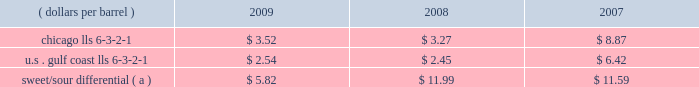Our refining and wholesale marketing gross margin is the difference between the prices of refined products sold and the costs of crude oil and other charge and blendstocks refined , including the costs to transport these inputs to our refineries , the costs of purchased products and manufacturing expenses , including depreciation .
The crack spread is a measure of the difference between market prices for refined products and crude oil , commonly used by the industry as a proxy for the refining margin .
Crack spreads can fluctuate significantly , particularly when prices of refined products do not move in the same relationship as the cost of crude oil .
As a performance benchmark and a comparison with other industry participants , we calculate midwest ( chicago ) and u.s .
Gulf coast crack spreads that we feel most closely track our operations and slate of products .
Posted light louisiana sweet ( 201clls 201d ) prices and a 6-3-2-1 ratio of products ( 6 barrels of crude oil producing 3 barrels of gasoline , 2 barrels of distillate and 1 barrel of residual fuel ) are used for the crack spread calculation .
Our refineries can process significant amounts of sour crude oil which typically can be purchased at a discount to sweet crude oil .
The amount of this discount , the sweet/sour differential , can vary significantly causing our refining and wholesale marketing gross margin to differ from the crack spreads which are based upon sweet crude .
In general , a larger sweet/sour differential will enhance our refining and wholesale marketing gross margin .
In 2009 , the sweet/sour differential narrowed , due to a variety of worldwide economic and petroleum industry related factors , primarily related to lower hydrocarbon demand .
Sour crude accounted for 50 percent , 52 percent and 54 percent of our crude oil processed in 2009 , 2008 and 2007 .
The table lists calculated average crack spreads for the midwest ( chicago ) and gulf coast markets and the sweet/sour differential for the past three years .
( dollars per barrel ) 2009 2008 2007 .
Sweet/sour differential ( a ) $ 5.82 $ 11.99 $ 11.59 ( a ) calculated using the following mix of crude types as compared to lls. : 15% ( 15 % ) arab light , 20% ( 20 % ) kuwait , 10% ( 10 % ) maya , 15% ( 15 % ) western canadian select , 40% ( 40 % ) mars .
In addition to the market changes indicated by the crack spreads and sweet/sour differential , our refining and wholesale marketing gross margin is impacted by factors such as : 2022 the types of crude oil and other charge and blendstocks processed , 2022 the selling prices realized for refined products , 2022 the impact of commodity derivative instruments used to manage price risk , 2022 the cost of products purchased for resale , and 2022 changes in manufacturing costs , which include depreciation .
Manufacturing costs are primarily driven by the cost of energy used by our refineries and the level of maintenance costs .
Planned turnaround and major maintenance activities were completed at our catlettsburg , garyville , and robinson refineries in 2009 .
We performed turnaround and major maintenance activities at our robinson , catlettsburg , garyville and canton refineries in 2008 and at our catlettsburg , robinson and st .
Paul park refineries in 2007 .
Our retail marketing gross margin for gasoline and distillates , which is the difference between the ultimate price paid by consumers and the cost of refined products , including secondary transportation and consumer excise taxes , also impacts rm&t segment profitability .
There are numerous factors including local competition , seasonal demand fluctuations , the available wholesale supply , the level of economic activity in our marketing areas and weather conditions that impact gasoline and distillate demand throughout the year .
Refined product demand increased for several years until 2008 when it decreased due to the combination of significant increases in retail petroleum prices , a broad slowdown in general economic activity , and the impact of increased ethanol blending into gasoline .
In 2009 refined product demand continued to decline .
For our marketing area , we estimate a gasoline demand decline of about one percent and a distillate demand decline of about 12 percent from 2008 levels .
Market demand declines for gasoline and distillates generally reduce the product margin we can realize .
We also estimate gasoline and distillate demand in our marketing area decreased about three percent in 2008 compared to 2007 levels .
The gross margin on merchandise sold at retail outlets has been historically less volatile. .
By what percentage did the average crack spread for the midwest ( chicago ) decrease from 2007 to 2009? 
Computations: ((3.52 - 8.87) / 8.87)
Answer: -0.60316. 